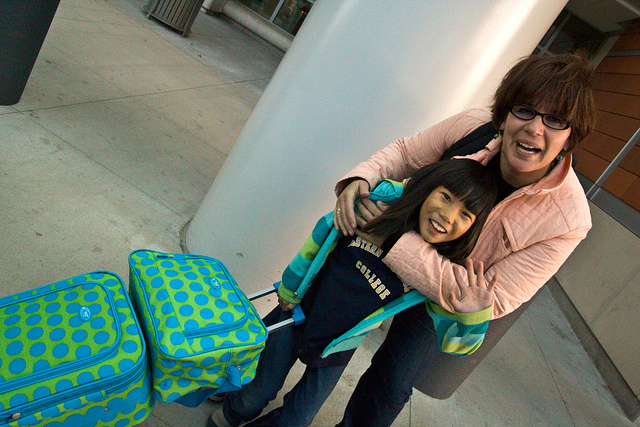Why is the young girl holding luggage? The young girl appears to be holding luggage most likely because she is preparing to travel. The luggage and her happy demeanor suggest she is about to embark on a journey, possibly a vacation or a visit to a new place, accompanied by an adult who seems to be sharing the moment with joy. 